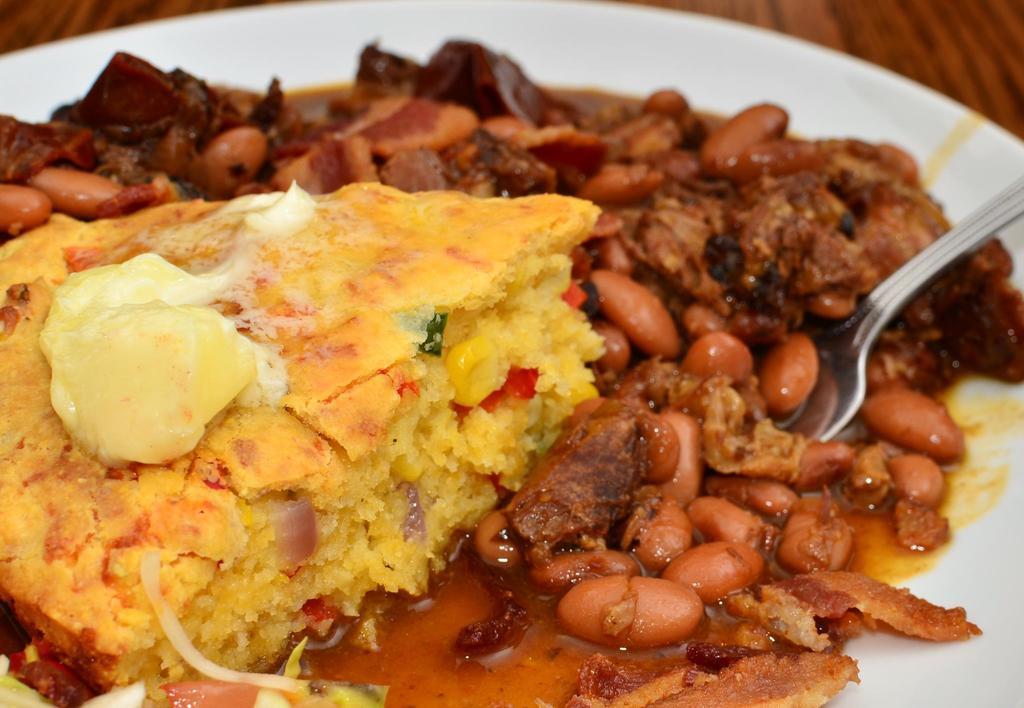Could you give a brief overview of what you see in this image? In this image we can see a food item on the plate, there is a spoon, there is a wooden table. 